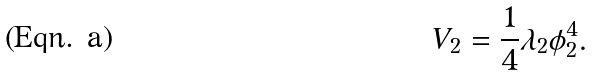Convert formula to latex. <formula><loc_0><loc_0><loc_500><loc_500>V _ { 2 } = \frac { 1 } { 4 } \lambda _ { 2 } \phi _ { 2 } ^ { 4 } .</formula> 